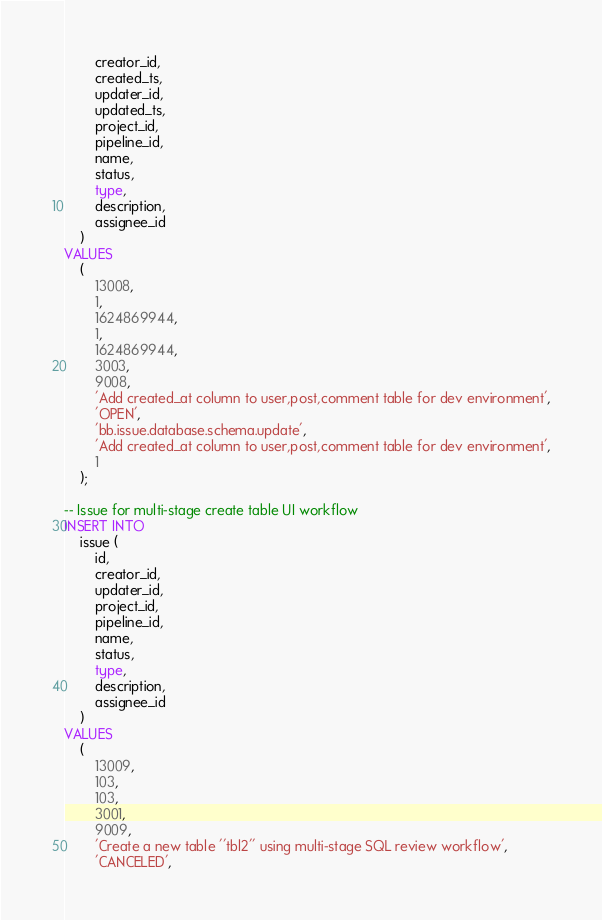Convert code to text. <code><loc_0><loc_0><loc_500><loc_500><_SQL_>        creator_id,
        created_ts,
        updater_id,
        updated_ts,
        project_id,
        pipeline_id,
        name,
        status,
        type,
        description,
        assignee_id
    )
VALUES
    (
        13008,
        1,
        1624869944,
        1,
        1624869944,
        3003,
        9008,
        'Add created_at column to user,post,comment table for dev environment',
        'OPEN',
        'bb.issue.database.schema.update',
        'Add created_at column to user,post,comment table for dev environment',
        1
    );

-- Issue for multi-stage create table UI workflow
INSERT INTO
    issue (
        id,
        creator_id,
        updater_id,
        project_id,
        pipeline_id,
        name,
        status,
        type,
        description,
        assignee_id
    )
VALUES
    (
        13009,
        103,
        103,
        3001,
        9009,
        'Create a new table ''tbl2'' using multi-stage SQL review workflow',
        'CANCELED',</code> 